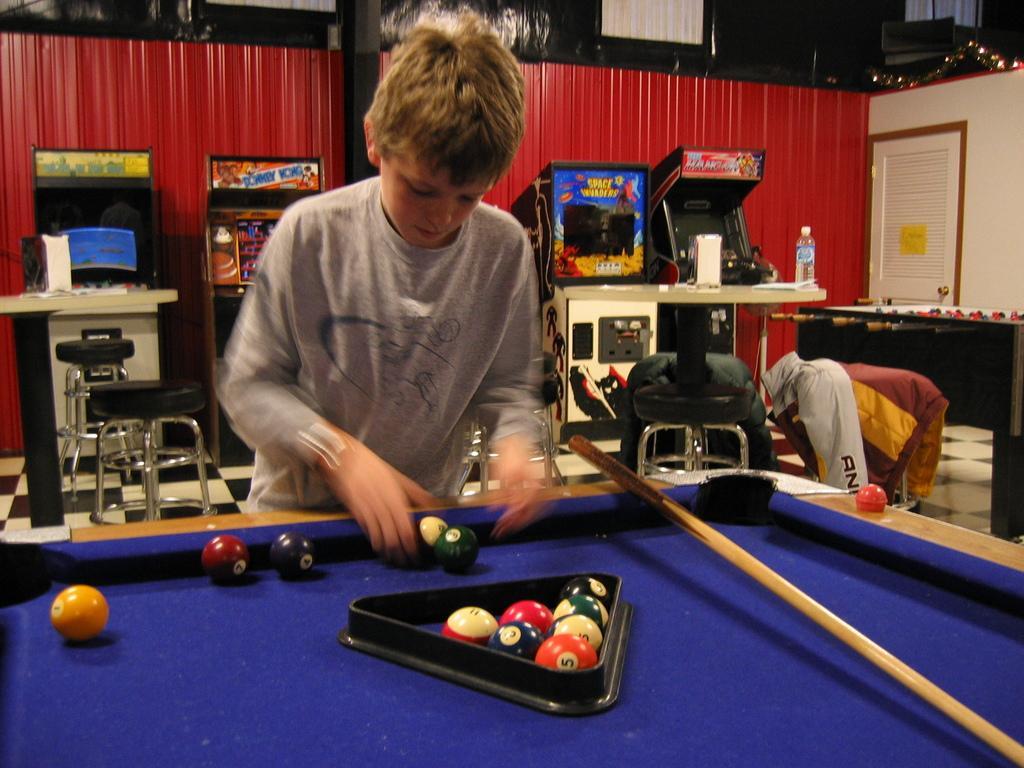How would you summarize this image in a sentence or two? In this image we can see a kid standing near a snooker table, there are balls and a stick on the table, there are few stools, jacket on the stool and a table with a bottle and few objects on the table and there are few objects in the background. 